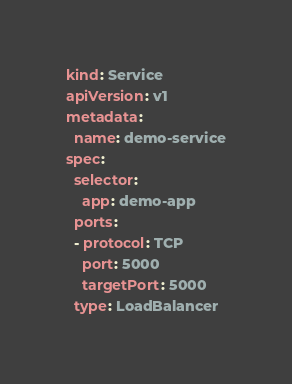Convert code to text. <code><loc_0><loc_0><loc_500><loc_500><_YAML_>kind: Service
apiVersion: v1
metadata:
  name: demo-service
spec:
  selector:
    app: demo-app
  ports:
  - protocol: TCP
    port: 5000
    targetPort: 5000
  type: LoadBalancer</code> 